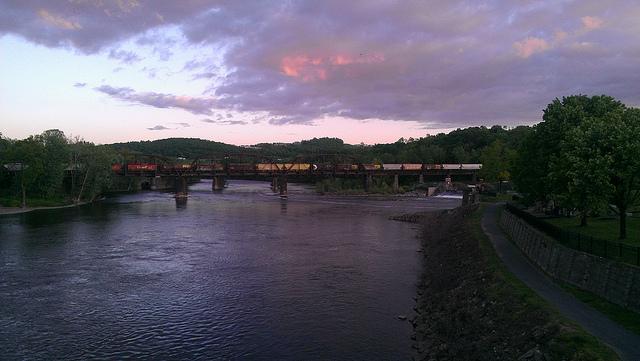How many boats are on the water?
Give a very brief answer. 0. 